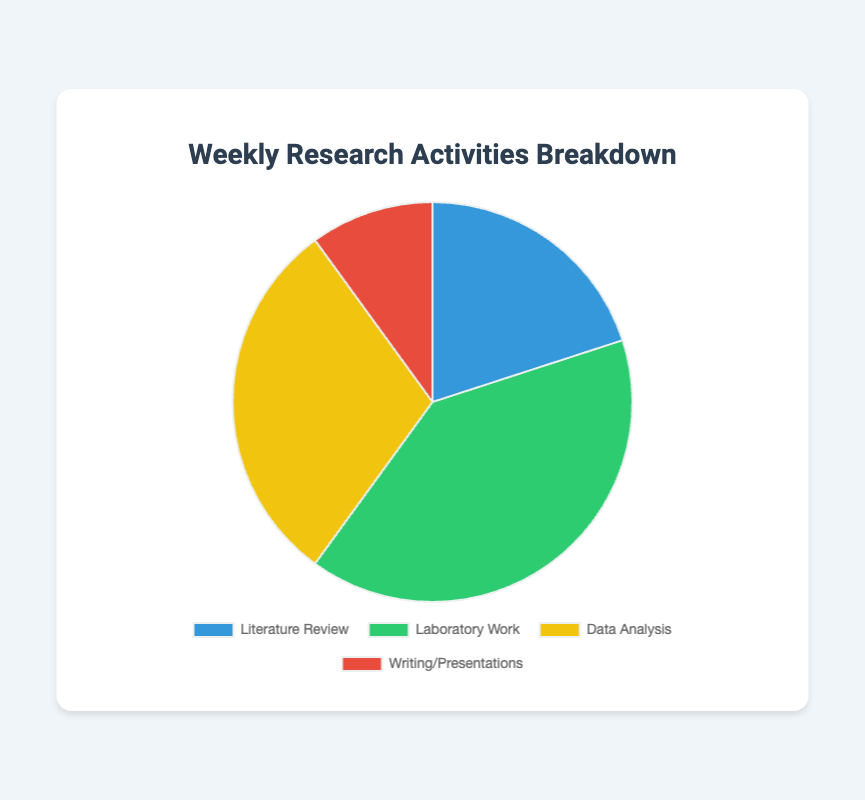Which activity takes up the most time per week? The figure shows the time spent on various activities represented as portions of a pie chart. The largest portion corresponds to Laboratory Work, which is 20 hours per week.
Answer: Laboratory Work What percentage of the total time is spent on Data Analysis? The total time spent on all activities is 50 hours per week (10 + 20 + 15 + 5). Data Analysis is 15 hours, so the percentage is (15 / 50) * 100 = 30%.
Answer: 30% How does the time spent on Literature Review compare to Writing/Presentations? Literature Review is shown as a larger section of the pie chart than Writing/Presentations. Literature Review is 10 hours, while Writing/Presentations is 5 hours. Therefore, double the time is spent on Literature Review compared to Writing/Presentations.
Answer: Double What's the sum of time spent on Literature Review and Data Analysis? Add the times for Literature Review (10 hours) and Data Analysis (15 hours). The sum is 10 + 15 = 25 hours.
Answer: 25 hours What is the difference between the time spent on Laboratory Work and Literature Review? Subtract the time spent on Literature Review (10 hours) from the time spent on Laboratory Work (20 hours). The difference is 20 - 10 = 10 hours.
Answer: 10 hours Which activity takes the least amount of time per week, and how much time is spent on it? The smallest section of the pie chart corresponds to Writing/Presentations. The time spent on it is 5 hours per week.
Answer: Writing/Presentations, 5 hours What is the average time spent per week on each activity? Sum the time spent on all activities, which is 50 hours, and divide by the number of activities (4). The average is 50 / 4 = 12.5 hours per activity.
Answer: 12.5 hours How much more time is spent on Laboratory Work and Data Analysis combined compared to Writing/Presentations and Literature Review combined? Add the times spent on Laboratory Work (20 hours) and Data Analysis (15 hours), which totals 35 hours. Add the times spent on Writing/Presentations (5 hours) and Literature Review (10 hours), which totals 15 hours. The difference is 35 - 15 = 20 hours.
Answer: 20 hours 